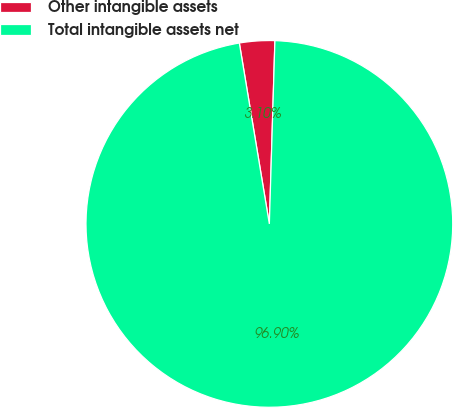<chart> <loc_0><loc_0><loc_500><loc_500><pie_chart><fcel>Other intangible assets<fcel>Total intangible assets net<nl><fcel>3.1%<fcel>96.9%<nl></chart> 